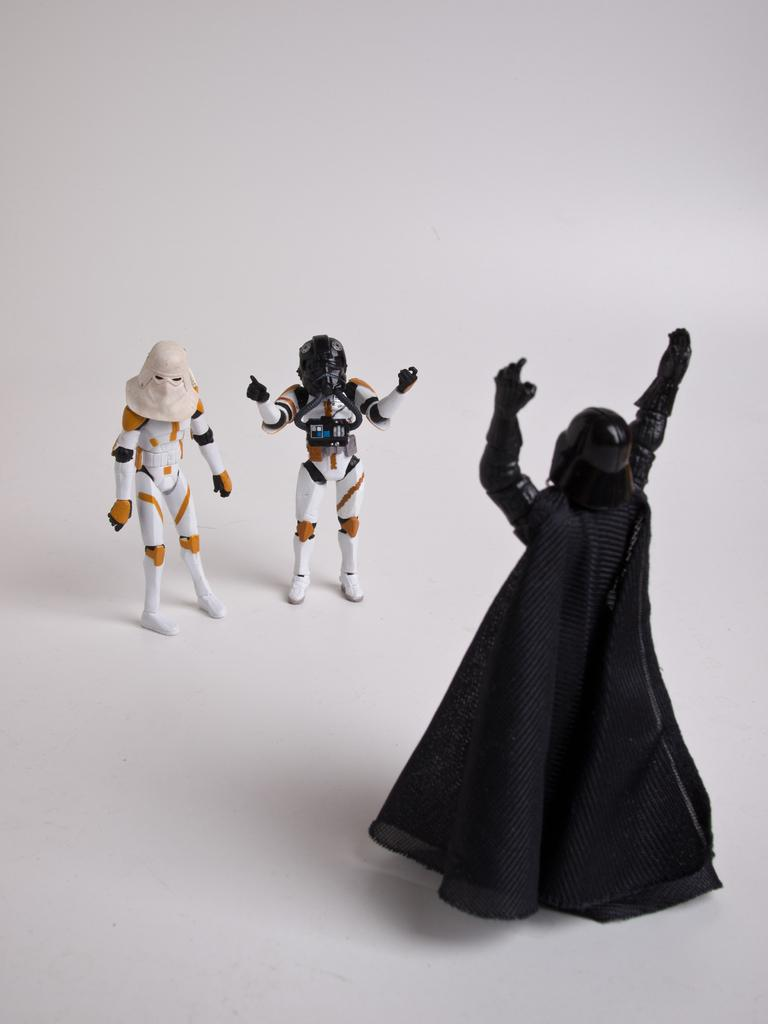What objects are present in the image? There are toys in the image. What color is the background of the image? The background of the image is white. What decision was made during the dinner in the image? There is no dinner or decision-making process depicted in the image; it features toys and a white background. 